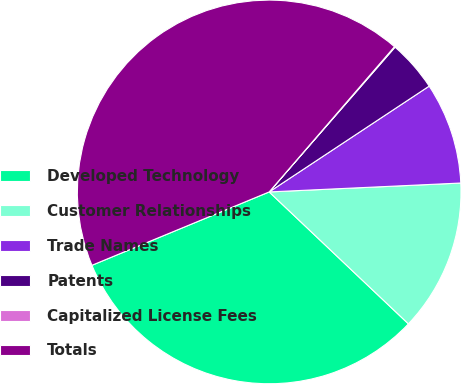Convert chart. <chart><loc_0><loc_0><loc_500><loc_500><pie_chart><fcel>Developed Technology<fcel>Customer Relationships<fcel>Trade Names<fcel>Patents<fcel>Capitalized License Fees<fcel>Totals<nl><fcel>31.68%<fcel>12.81%<fcel>8.56%<fcel>4.31%<fcel>0.06%<fcel>42.57%<nl></chart> 